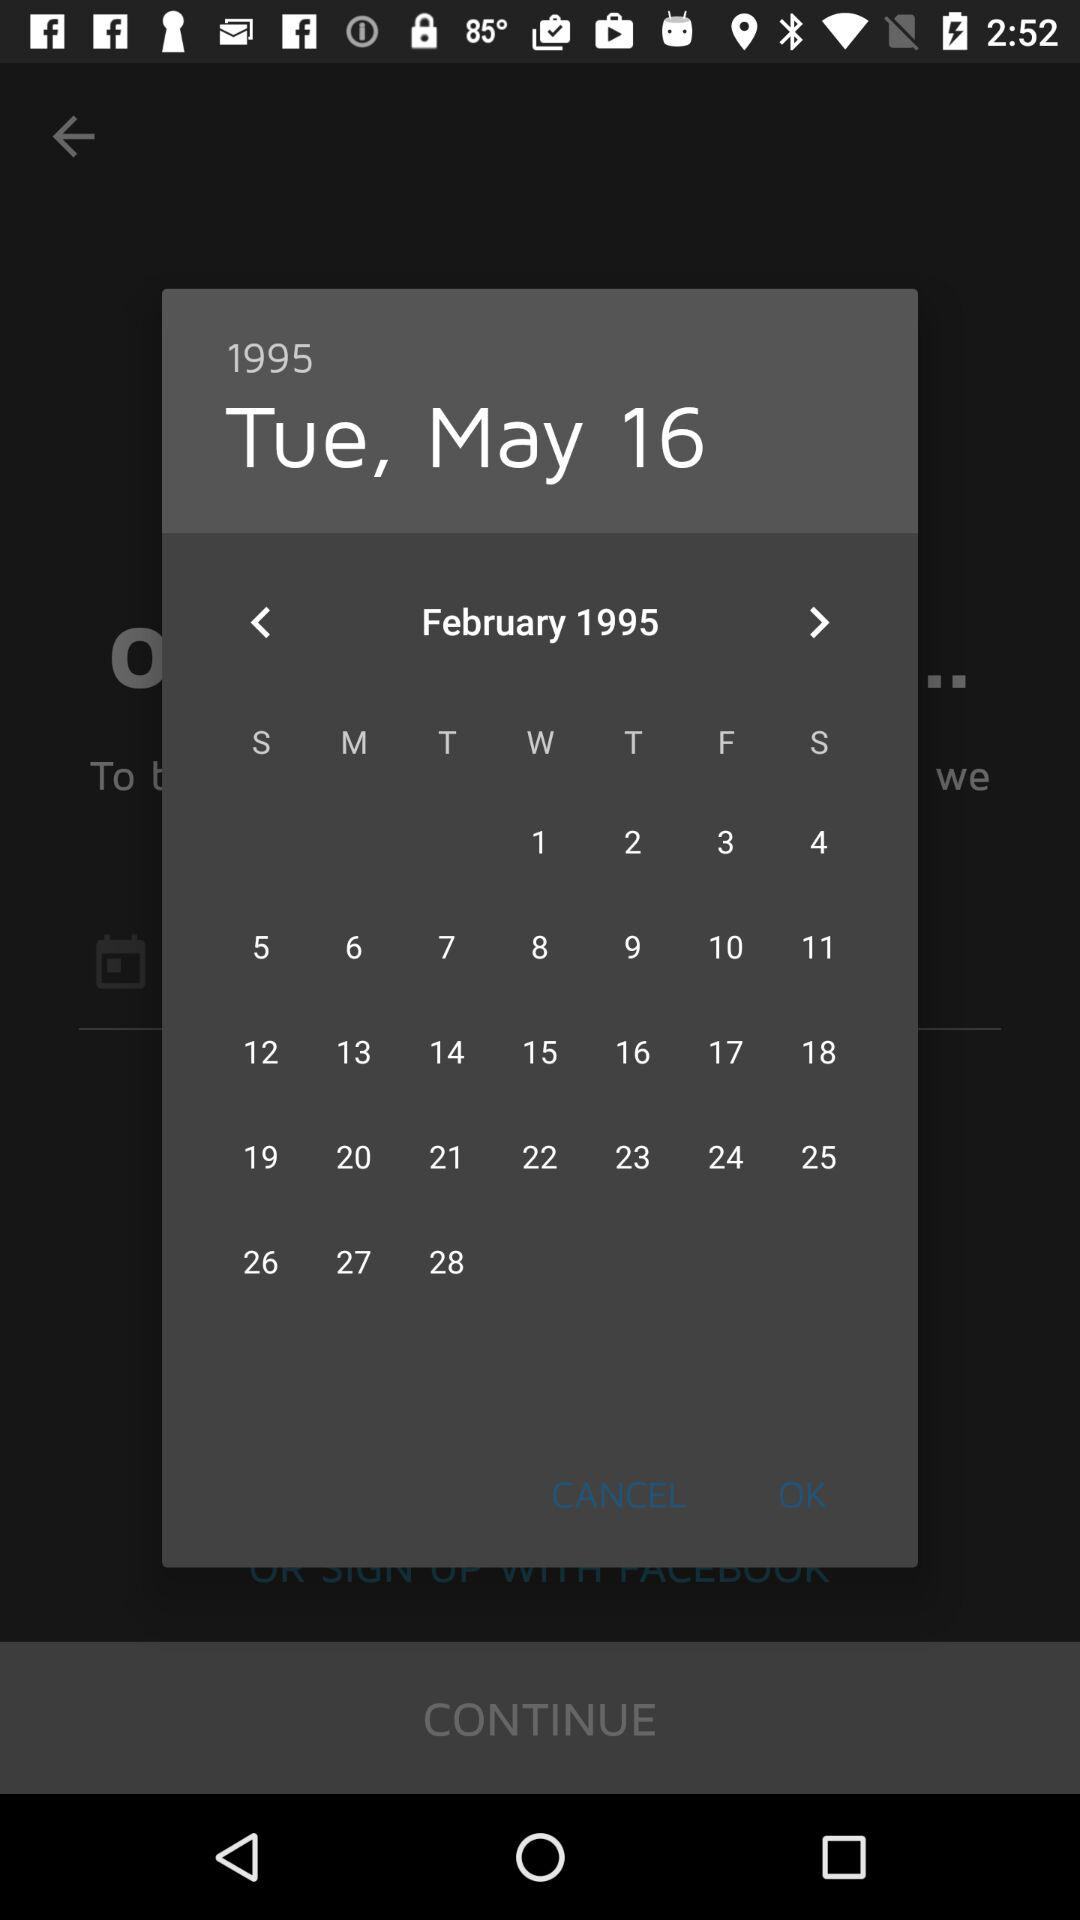What is the selected date? The selected date is Tuesday, May 16, 1995. 